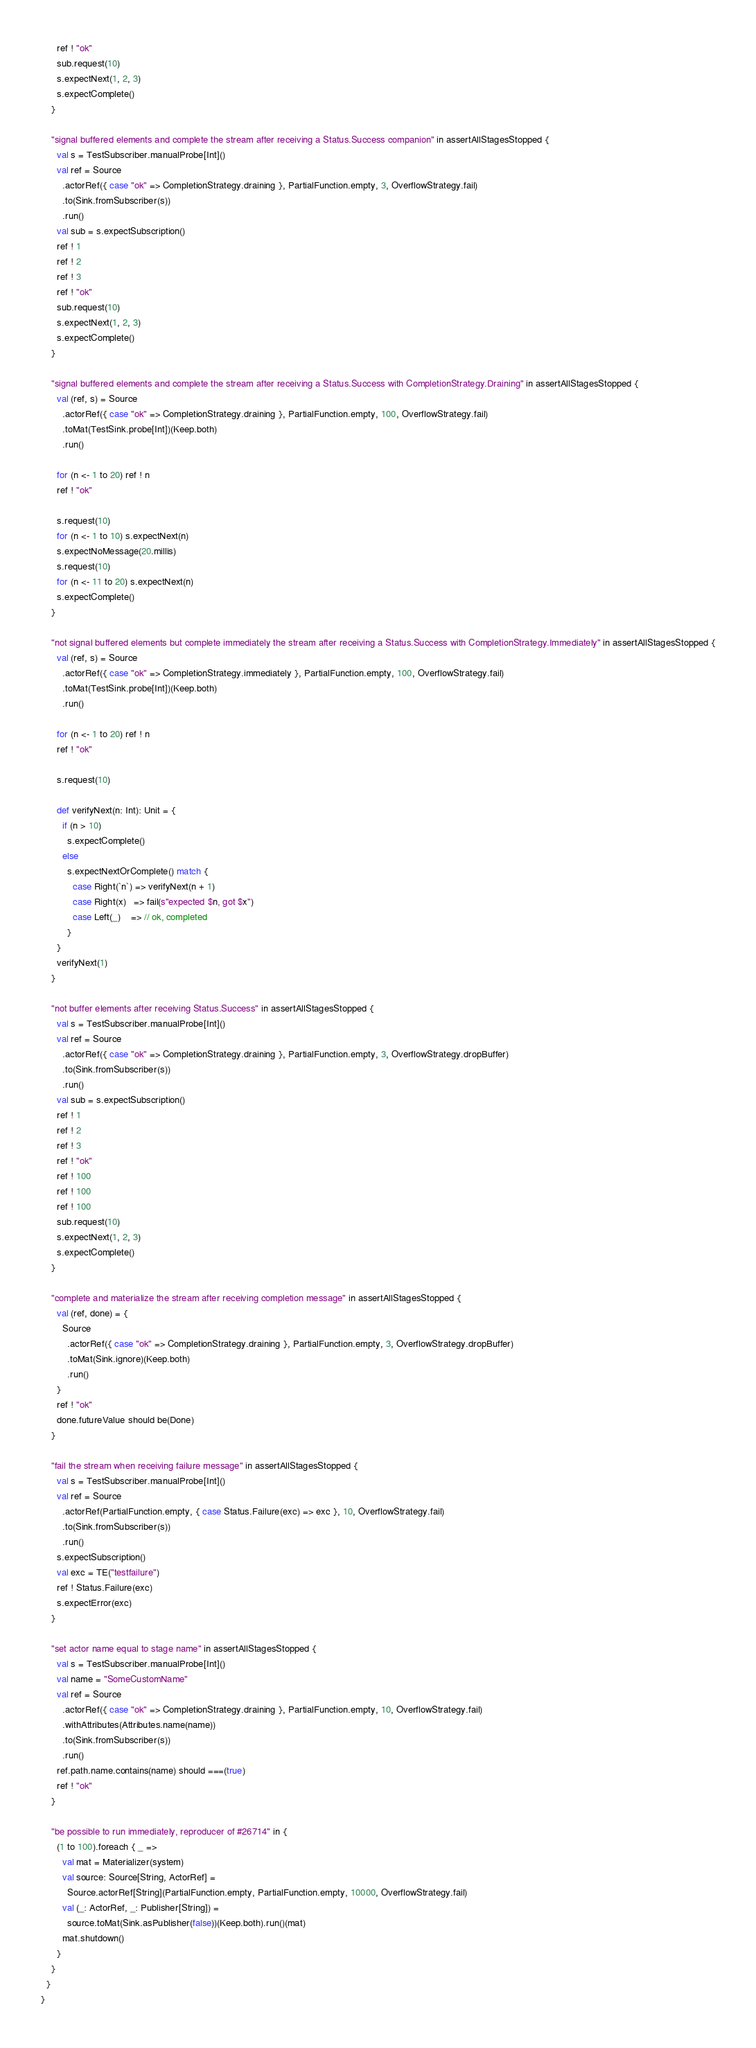<code> <loc_0><loc_0><loc_500><loc_500><_Scala_>      ref ! "ok"
      sub.request(10)
      s.expectNext(1, 2, 3)
      s.expectComplete()
    }

    "signal buffered elements and complete the stream after receiving a Status.Success companion" in assertAllStagesStopped {
      val s = TestSubscriber.manualProbe[Int]()
      val ref = Source
        .actorRef({ case "ok" => CompletionStrategy.draining }, PartialFunction.empty, 3, OverflowStrategy.fail)
        .to(Sink.fromSubscriber(s))
        .run()
      val sub = s.expectSubscription()
      ref ! 1
      ref ! 2
      ref ! 3
      ref ! "ok"
      sub.request(10)
      s.expectNext(1, 2, 3)
      s.expectComplete()
    }

    "signal buffered elements and complete the stream after receiving a Status.Success with CompletionStrategy.Draining" in assertAllStagesStopped {
      val (ref, s) = Source
        .actorRef({ case "ok" => CompletionStrategy.draining }, PartialFunction.empty, 100, OverflowStrategy.fail)
        .toMat(TestSink.probe[Int])(Keep.both)
        .run()

      for (n <- 1 to 20) ref ! n
      ref ! "ok"

      s.request(10)
      for (n <- 1 to 10) s.expectNext(n)
      s.expectNoMessage(20.millis)
      s.request(10)
      for (n <- 11 to 20) s.expectNext(n)
      s.expectComplete()
    }

    "not signal buffered elements but complete immediately the stream after receiving a Status.Success with CompletionStrategy.Immediately" in assertAllStagesStopped {
      val (ref, s) = Source
        .actorRef({ case "ok" => CompletionStrategy.immediately }, PartialFunction.empty, 100, OverflowStrategy.fail)
        .toMat(TestSink.probe[Int])(Keep.both)
        .run()

      for (n <- 1 to 20) ref ! n
      ref ! "ok"

      s.request(10)

      def verifyNext(n: Int): Unit = {
        if (n > 10)
          s.expectComplete()
        else
          s.expectNextOrComplete() match {
            case Right(`n`) => verifyNext(n + 1)
            case Right(x)   => fail(s"expected $n, got $x")
            case Left(_)    => // ok, completed
          }
      }
      verifyNext(1)
    }

    "not buffer elements after receiving Status.Success" in assertAllStagesStopped {
      val s = TestSubscriber.manualProbe[Int]()
      val ref = Source
        .actorRef({ case "ok" => CompletionStrategy.draining }, PartialFunction.empty, 3, OverflowStrategy.dropBuffer)
        .to(Sink.fromSubscriber(s))
        .run()
      val sub = s.expectSubscription()
      ref ! 1
      ref ! 2
      ref ! 3
      ref ! "ok"
      ref ! 100
      ref ! 100
      ref ! 100
      sub.request(10)
      s.expectNext(1, 2, 3)
      s.expectComplete()
    }

    "complete and materialize the stream after receiving completion message" in assertAllStagesStopped {
      val (ref, done) = {
        Source
          .actorRef({ case "ok" => CompletionStrategy.draining }, PartialFunction.empty, 3, OverflowStrategy.dropBuffer)
          .toMat(Sink.ignore)(Keep.both)
          .run()
      }
      ref ! "ok"
      done.futureValue should be(Done)
    }

    "fail the stream when receiving failure message" in assertAllStagesStopped {
      val s = TestSubscriber.manualProbe[Int]()
      val ref = Source
        .actorRef(PartialFunction.empty, { case Status.Failure(exc) => exc }, 10, OverflowStrategy.fail)
        .to(Sink.fromSubscriber(s))
        .run()
      s.expectSubscription()
      val exc = TE("testfailure")
      ref ! Status.Failure(exc)
      s.expectError(exc)
    }

    "set actor name equal to stage name" in assertAllStagesStopped {
      val s = TestSubscriber.manualProbe[Int]()
      val name = "SomeCustomName"
      val ref = Source
        .actorRef({ case "ok" => CompletionStrategy.draining }, PartialFunction.empty, 10, OverflowStrategy.fail)
        .withAttributes(Attributes.name(name))
        .to(Sink.fromSubscriber(s))
        .run()
      ref.path.name.contains(name) should ===(true)
      ref ! "ok"
    }

    "be possible to run immediately, reproducer of #26714" in {
      (1 to 100).foreach { _ =>
        val mat = Materializer(system)
        val source: Source[String, ActorRef] =
          Source.actorRef[String](PartialFunction.empty, PartialFunction.empty, 10000, OverflowStrategy.fail)
        val (_: ActorRef, _: Publisher[String]) =
          source.toMat(Sink.asPublisher(false))(Keep.both).run()(mat)
        mat.shutdown()
      }
    }
  }
}
</code> 